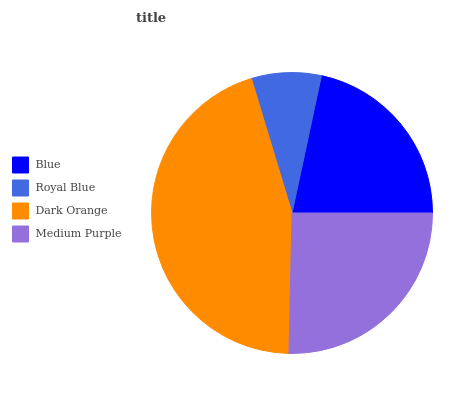Is Royal Blue the minimum?
Answer yes or no. Yes. Is Dark Orange the maximum?
Answer yes or no. Yes. Is Dark Orange the minimum?
Answer yes or no. No. Is Royal Blue the maximum?
Answer yes or no. No. Is Dark Orange greater than Royal Blue?
Answer yes or no. Yes. Is Royal Blue less than Dark Orange?
Answer yes or no. Yes. Is Royal Blue greater than Dark Orange?
Answer yes or no. No. Is Dark Orange less than Royal Blue?
Answer yes or no. No. Is Medium Purple the high median?
Answer yes or no. Yes. Is Blue the low median?
Answer yes or no. Yes. Is Blue the high median?
Answer yes or no. No. Is Dark Orange the low median?
Answer yes or no. No. 